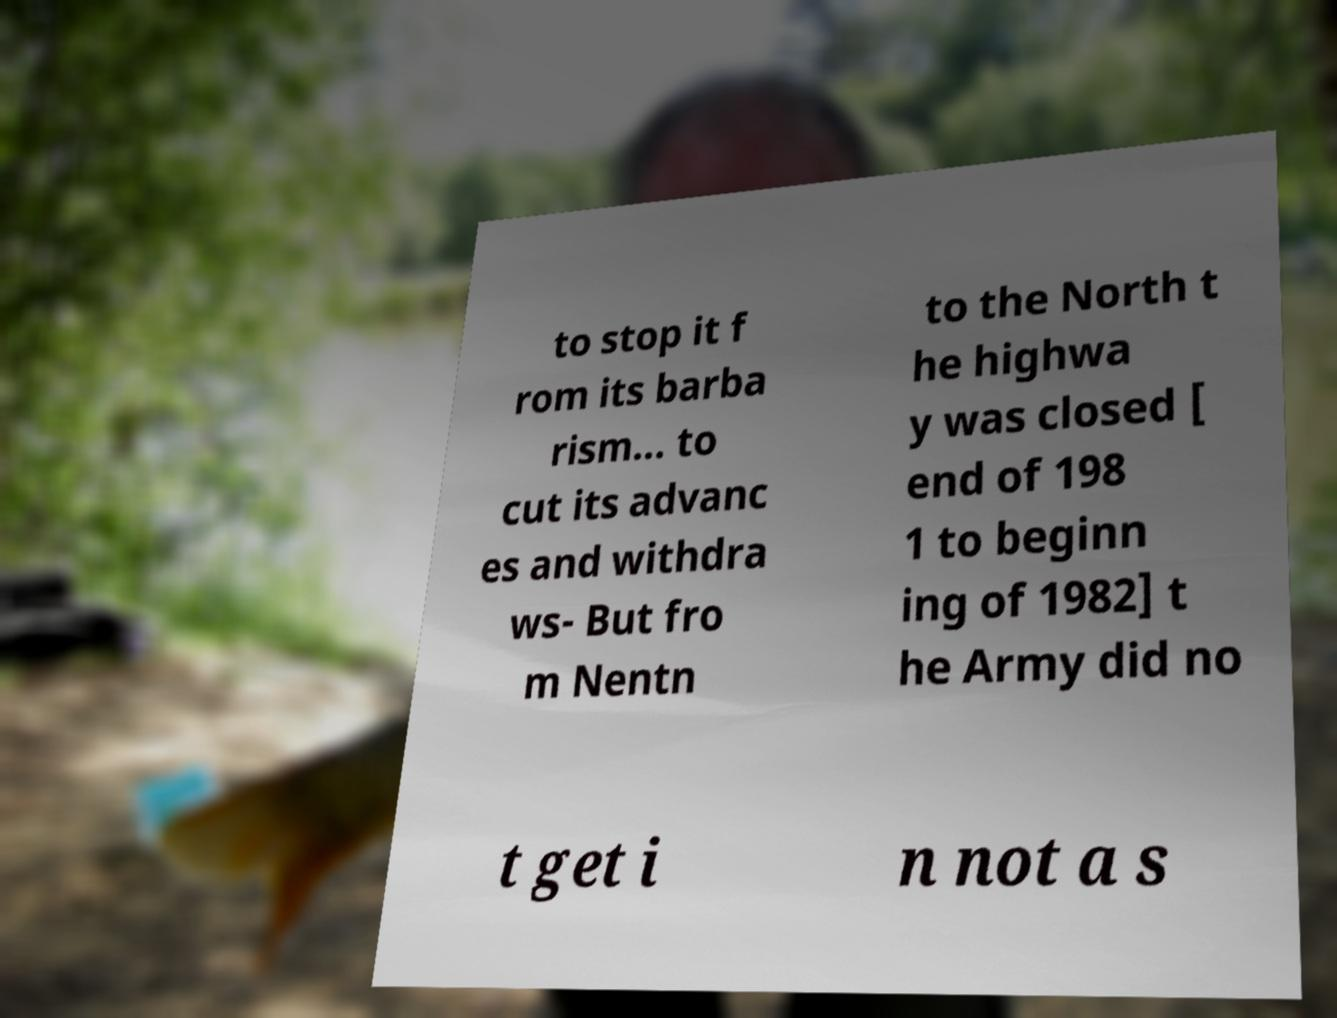Can you accurately transcribe the text from the provided image for me? to stop it f rom its barba rism... to cut its advanc es and withdra ws- But fro m Nentn to the North t he highwa y was closed [ end of 198 1 to beginn ing of 1982] t he Army did no t get i n not a s 